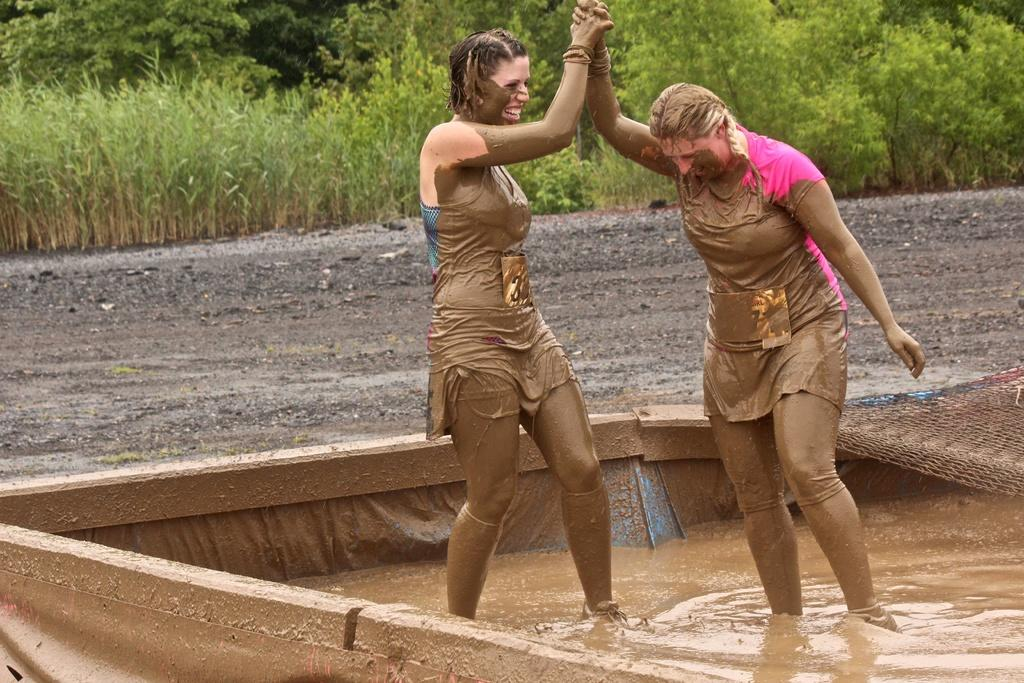How many women are in the image? There are two women in the image. What are the women doing in the image? The women are standing in the mud and holding hands. What can be seen in the background of the image? There are trees and plants in the image. What is the expression on the women's faces? The women are smiling in the image. What type of locket can be seen around the neck of one of the women in the image? There is no locket visible around the neck of either woman in the image. What songs are the women singing in the image? There is no indication that the women are singing in the image. 